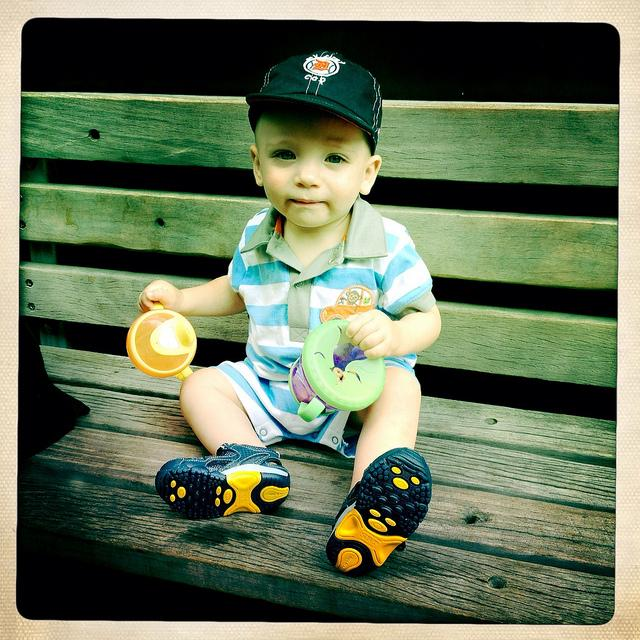What book series does he probably like? curious george 